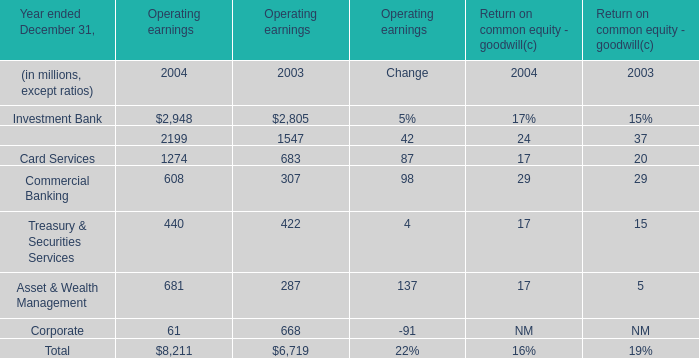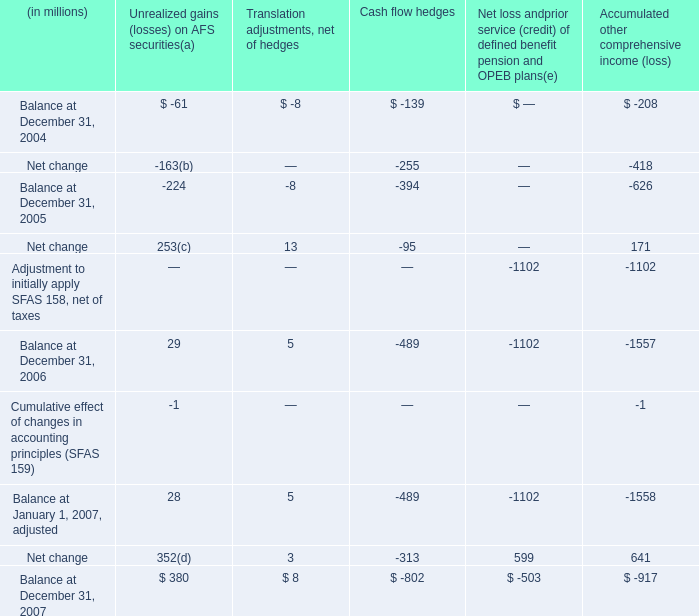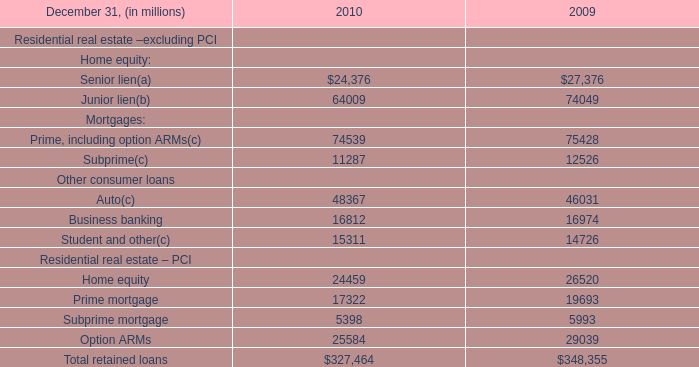what was the percentage change in unrealized gains ( losses ) on afs securities from december 31 , 2006 to december 31 , 2007? 
Computations: ((380 - 29) / 29)
Answer: 12.10345. 